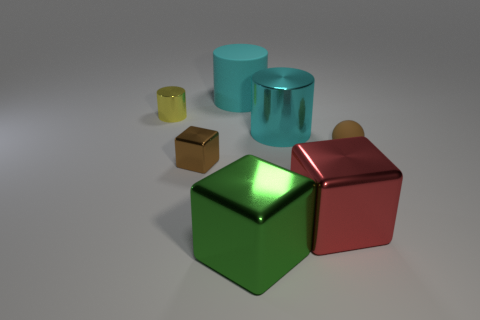Do the red metal object and the rubber cylinder have the same size?
Ensure brevity in your answer.  Yes. Is the number of large shiny cylinders that are in front of the red thing less than the number of large matte cylinders that are behind the small yellow metallic thing?
Provide a short and direct response. Yes. What size is the yellow metallic cylinder?
Provide a short and direct response. Small. What number of tiny things are brown blocks or matte cylinders?
Keep it short and to the point. 1. There is a cyan metallic cylinder; is it the same size as the metal cube that is right of the big metal cylinder?
Make the answer very short. Yes. Are there any other things that are the same shape as the small matte thing?
Offer a very short reply. No. What number of big yellow shiny things are there?
Your answer should be compact. 0. How many blue things are either small cubes or matte balls?
Keep it short and to the point. 0. Are the big cyan object that is on the left side of the large green shiny block and the large red cube made of the same material?
Keep it short and to the point. No. What number of other objects are there of the same material as the red block?
Give a very brief answer. 4. 